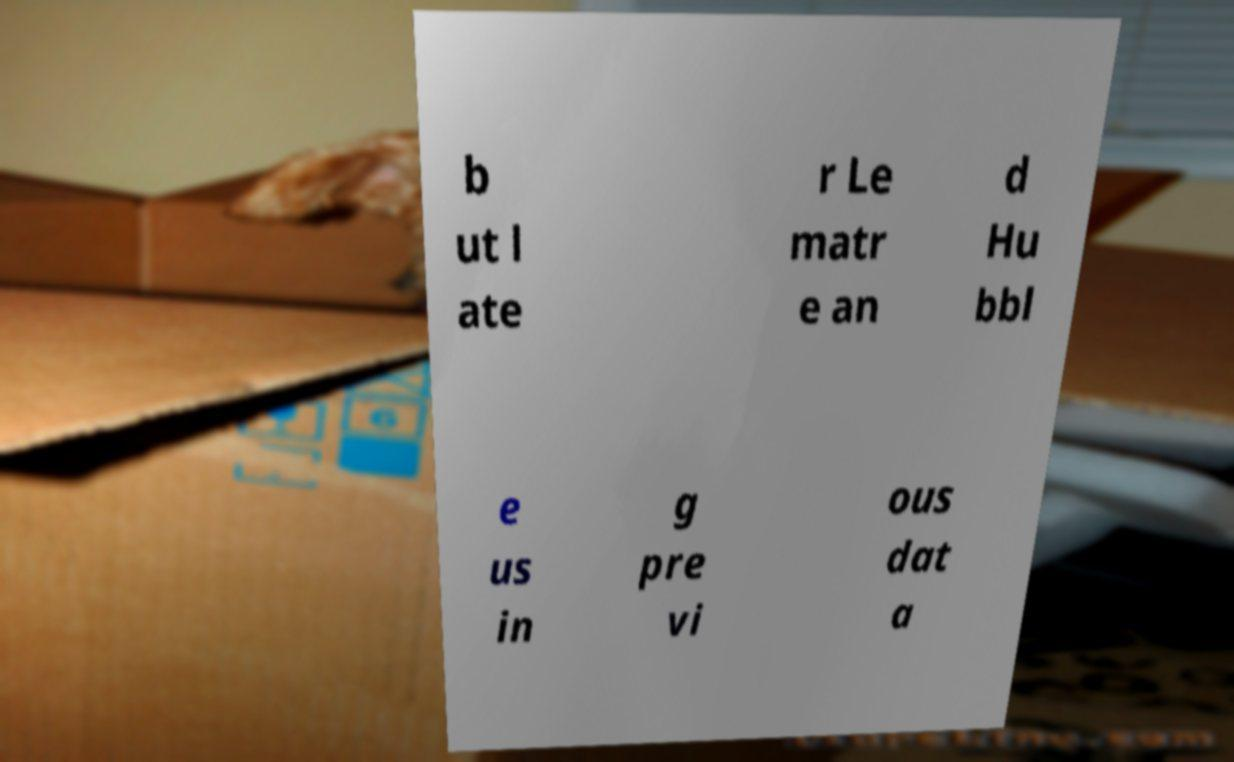What messages or text are displayed in this image? I need them in a readable, typed format. b ut l ate r Le matr e an d Hu bbl e us in g pre vi ous dat a 